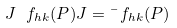<formula> <loc_0><loc_0><loc_500><loc_500>J \ f _ { h k } ( P ) J = \bar { \ } f _ { h k } ( P )</formula> 